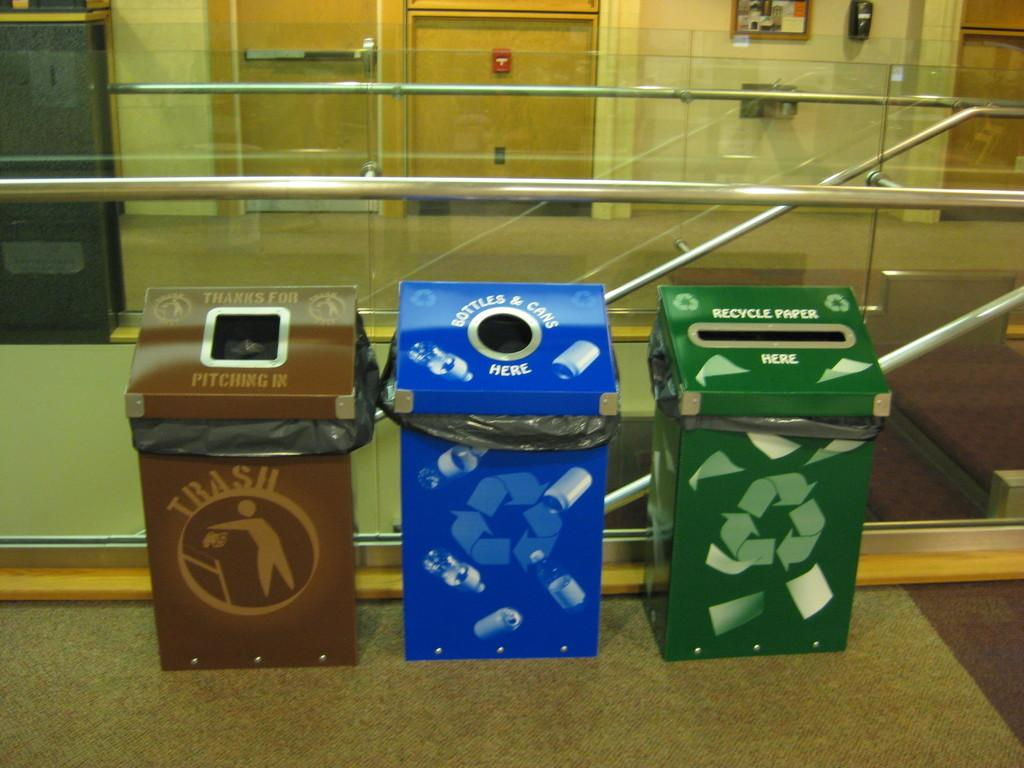<image>
Describe the image concisely. Three trash cans in a building and one has the word trash on it. 